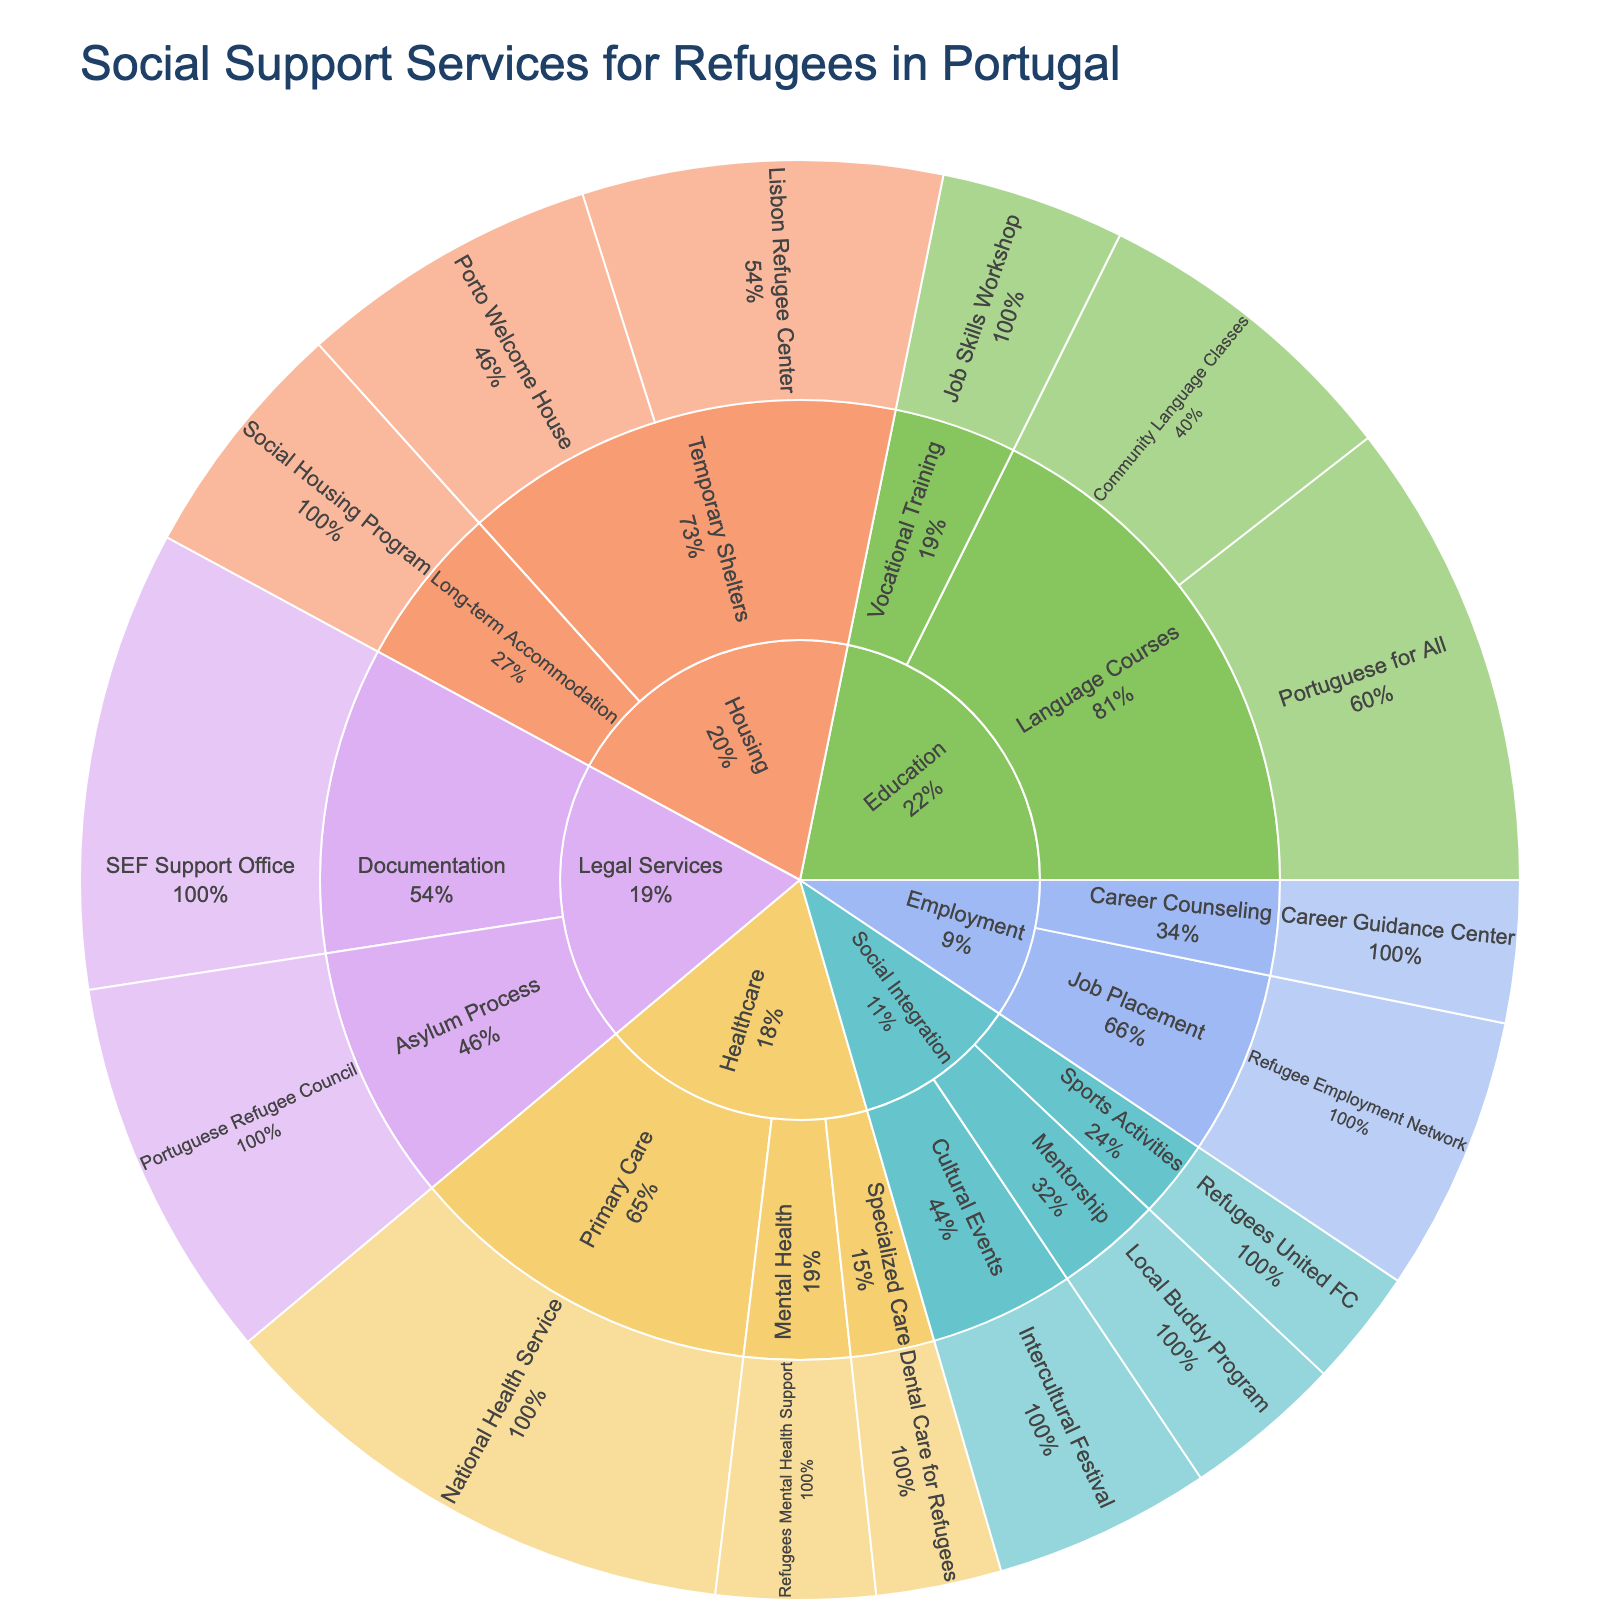What's the total usage of Housing services? To find the total usage of Housing services, you need to sum the usage of all subcategories under Housing: Temporary Shelters (215 + 180) and Long-term Accommodation (145). Therefore, the total usage is 215 + 180 + 145 = 540
Answer: 540 Which service under the Education category has the highest usage? Under the Education category, you have Language Courses (Portuguese for All: 280, Community Language Classes: 190) and Vocational Training (Job Skills Workshop: 110). The service with the highest usage is "Portuguese for All" with 280 usages.
Answer: Portuguese for All What's the difference in usage between the National Health Service and SEF Support Office? The usage for National Health Service is 320, and the usage for SEF Support Office is 275. The difference is 320 - 275 = 45
Answer: 45 Among the services for Social Integration, which one is utilized the least? The services under Social Integration are Cultural Events (Intercultural Festival: 130), Mentorship (Local Buddy Program: 95), and Sports Activities (Refugees United FC: 70). The least utilized service is "Refugees United FC" with 70 usages.
Answer: Refugees United FC Which category has the most diverse number of services? Each category has different numbers of subcategory services. To find the one with the most diversity, count the services under each category. The category with the most services listed is Housing (3 services) vs. Healthcare (3 services) vs. Education (3 services) vs. Employment (2 services) vs. Legal Services (2 services) vs. Social Integration (3 services). All but Employment and Legal Services have 3 services each.
Answer: Multiple (Housing, Healthcare, Education, Social Integration) In the Health category, what percent of the total healthcare service usage does Primary Care represent? The total healthcare usage is the sum of Primary Care (National Health Service: 320), Mental Health (Refugees Mental Health Support: 95), and Specialized Care (Dental Care for Refugees: 75), yielding a total of 320 + 95 + 75 = 490. The Primary Care usage is 320, so the percentage is (320 / 490) * 100 ≈ 65.31%.
Answer: ~65.31% Compare the usage between the Legal Services subcategories. Which is higher, Asylum Process or Documentation? The Asylum Process subcategory (Portuguese Refugee Council) has 230 usages and the Documentation subcategory (SEF Support Office) has 275 usages. Documentation is higher.
Answer: Documentation What's the combined usage of all Social Integration services? The Social Integration services and their usages are: Cultural Events (130), Mentorship (95), and Sports Activities (70). The combined usage is 130 + 95 + 70 = 295.
Answer: 295 Which Healthcare subcategory has the lowest service usage, and what is it? The subcategories under Healthcare are Primary Care (320), Mental Health (95), and Specialized Care (75). The lowest usage is Specialized Care (Dental Care for Refugees) with 75 usages.
Answer: Dental Care for Refugees How does the usage of the Local Buddy Program compare with the Job Skills Workshop? The Local Buddy Program has a usage of 95, and the Job Skills Workshop has a usage of 110. The Job Skills Workshop has higher usage.
Answer: Job Skills Workshop 